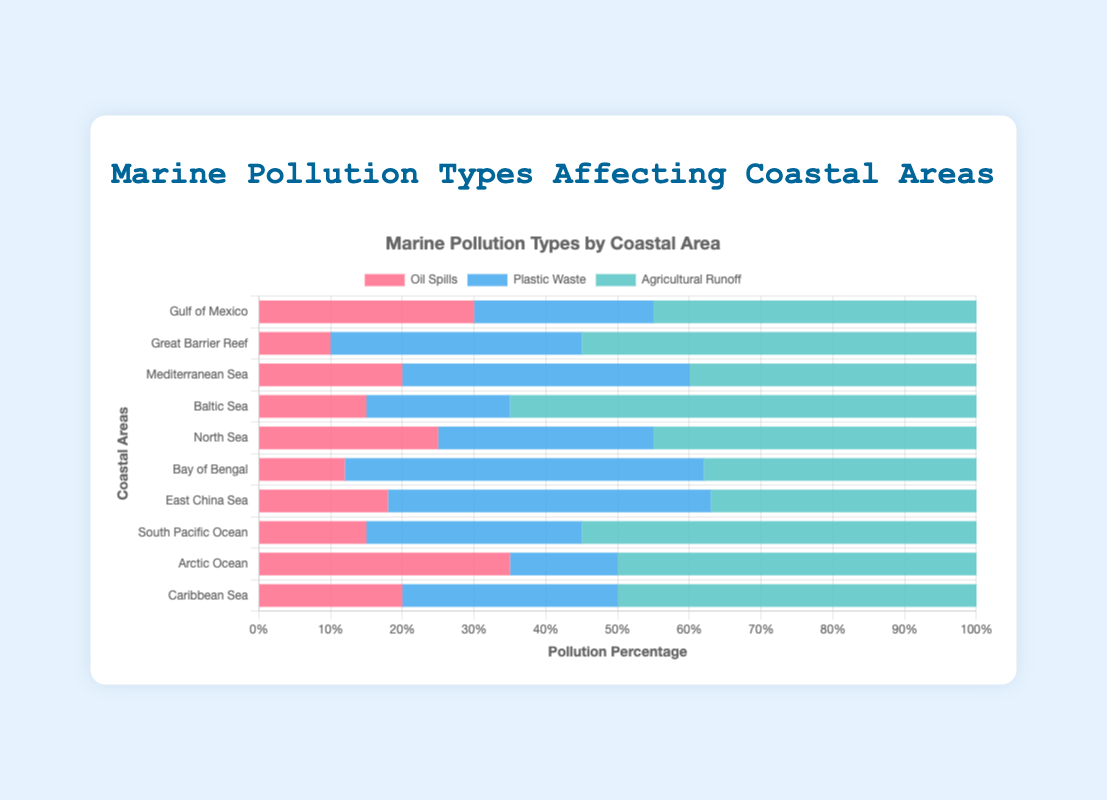What is the total percentage of pollution in the Mediterranean Sea? To find the total percentage, add the contributions from Oil Spills (20), Plastic Waste (40), and Agricultural Runoff (40): 20 + 40 + 40 = 100%.
Answer: 100% Which coastal area has the highest percentage of agricultural runoff pollution? By examining the chart, the area with the tallest segment in the color representing Agricultural Runoff is the Baltic Sea with 65%.
Answer: Baltic Sea Between the Gulf of Mexico and the Great Barrier Reef, which area has a higher percentage of plastic waste pollution and by how much? Compare the percentage of Plastic Waste for the Gulf of Mexico (25%) and the Great Barrier Reef (35%). The difference is 35% - 25% = 10%.
Answer: Great Barrier Reef by 10% What is the average percentage of oil spills across all coastal areas? Sum the oil spills percentages for all areas and divide by the number of areas: (30 + 10 + 20 + 15 + 25 + 12 + 18 + 15 + 35 + 20) / 10 = 200 / 10 = 20%.
Answer: 20% In which area does plastic waste contribute the largest share of total pollution? Identify the area with the highest percentage of Plastic Waste, which is the Bay of Bengal with 50%.
Answer: Bay of Bengal Which coastal area has the smallest percentage of oil spills? By looking at the chart, identify the shortest segment for Oil Spills, which is the Great Barrier Reef with 10%.
Answer: Great Barrier Reef Is the percentage of agricultural runoff pollution higher in the North Sea or the East China Sea, and by how much? Compare the Agricultural Runoff for North Sea (45%) and East China Sea (37%). The difference is 45% - 37% = 8%.
Answer: North Sea by 8% If we combined the percentages of plastic waste and agricultural runoff in the South Pacific Ocean, what would be the total percentage? Sum the percentages of Plastic Waste (30%) and Agricultural Runoff (55%) for the South Pacific Ocean. 30 + 55 = 85%.
Answer: 85% How does the pollution composition of the Arctic Ocean differ from the Caribbean Sea? Compare the segments: Arctic Ocean has 35% Oil Spills, 15% Plastic Waste, and 50% Agricultural Runoff. Caribbean Sea has 20% Oil Spills, 30% Plastic Waste, and 50% Agricultural Runoff. Arctic Ocean has higher oil spills (35% vs 20%) and lower plastic waste (15% vs 30%) but the same agricultural runoff (50%).
Answer: Arctic: more oil spills, less plastic waste, same agricultural runoff What's the difference in the total pollution percentage between the Gulf of Mexico and the Baltic Sea? Add the values for the Gulf of Mexico (30 + 25 + 45 = 100%) and the Baltic Sea (15 + 20 + 65 = 100%). Both are 100%, so the difference is 0%.
Answer: 0% 